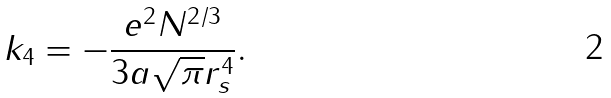<formula> <loc_0><loc_0><loc_500><loc_500>k _ { 4 } = - \frac { e ^ { 2 } N ^ { 2 / 3 } } { 3 a \sqrt { \pi } r _ { s } ^ { 4 } } .</formula> 